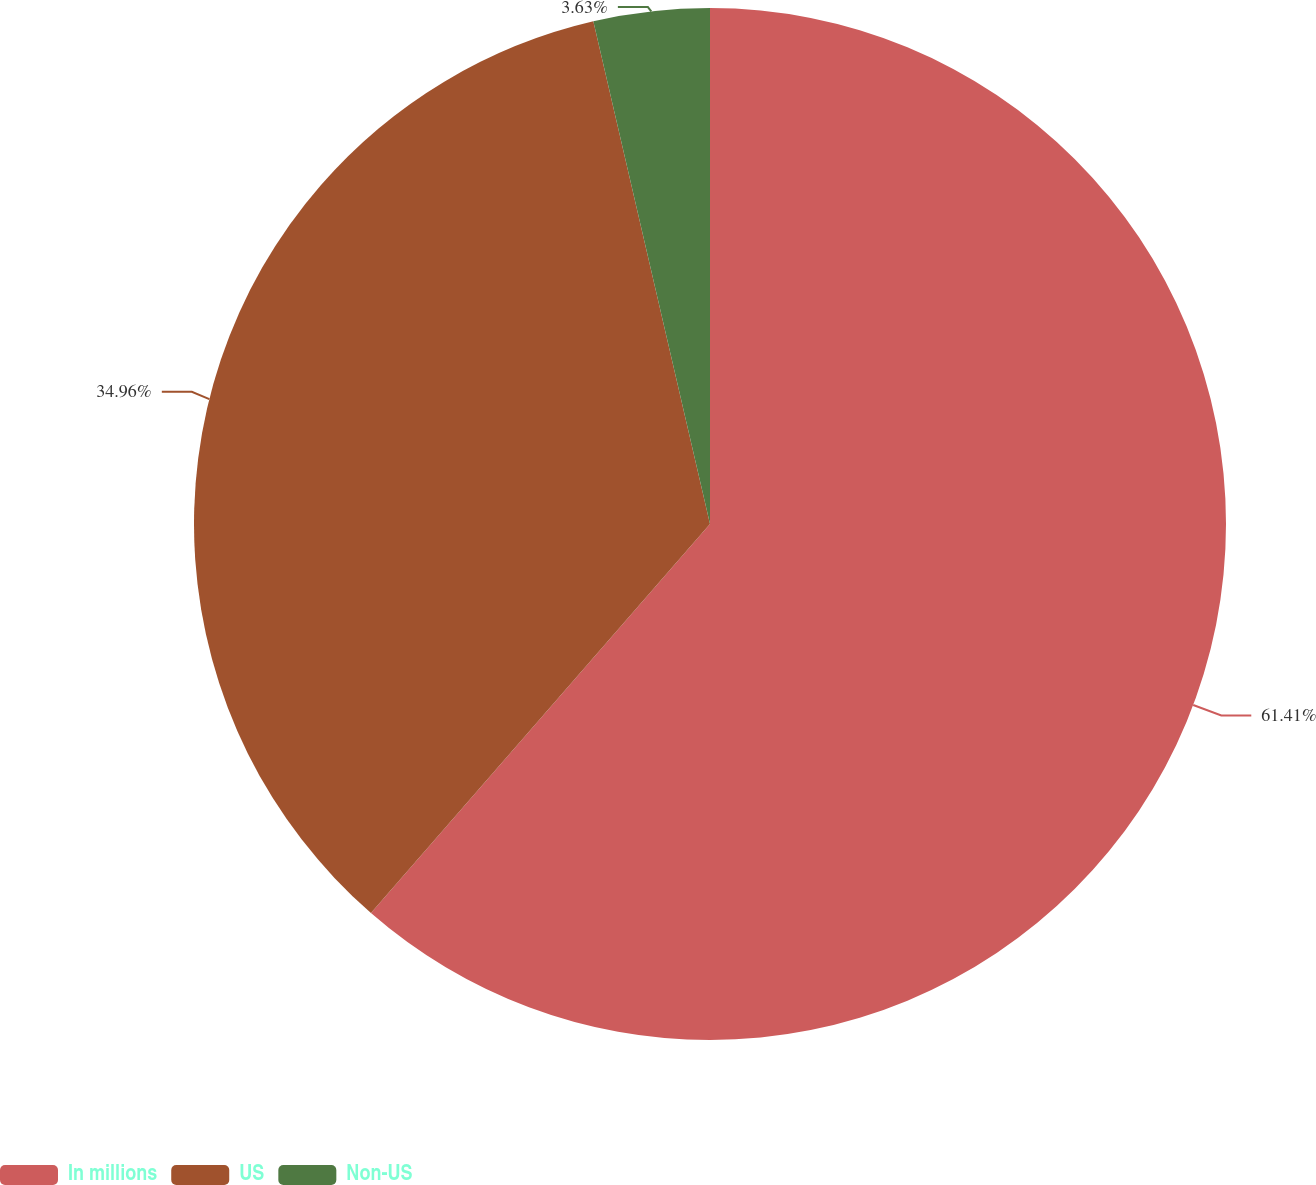Convert chart to OTSL. <chart><loc_0><loc_0><loc_500><loc_500><pie_chart><fcel>In millions<fcel>US<fcel>Non-US<nl><fcel>61.41%<fcel>34.96%<fcel>3.63%<nl></chart> 